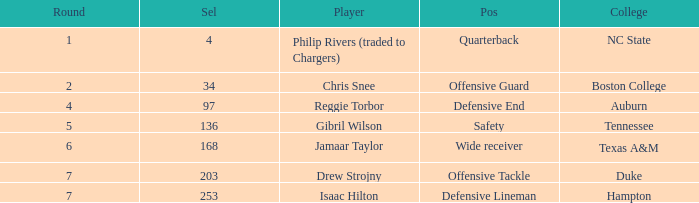Which Selection has a Player of jamaar taylor, and a Round larger than 6? None. 